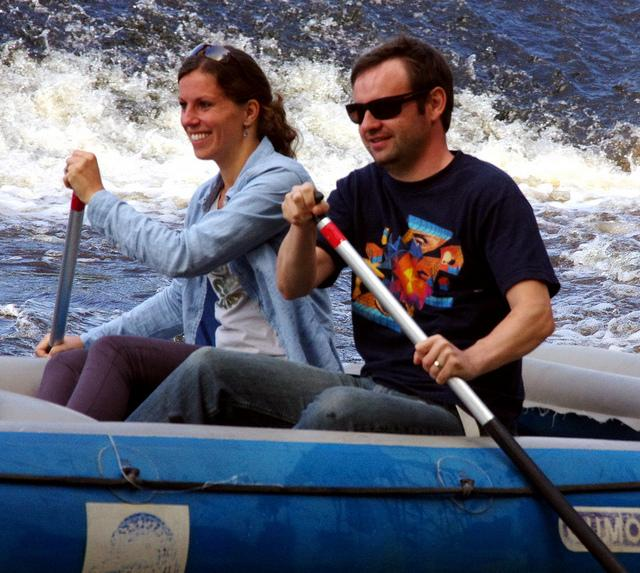What should they have worn before starting the activity? Please explain your reasoning. life jacket. People wear that in case they fall in the water. 